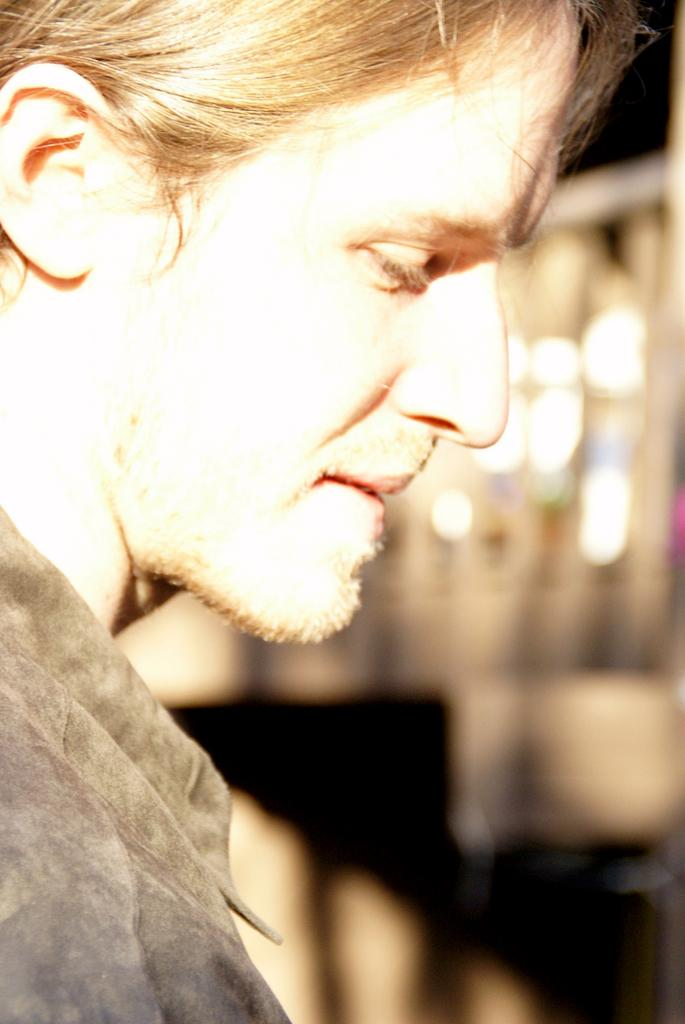What is the hair color of the person in the image? The person in the image has blonde hair. What type of clothing is the person wearing? The person is wearing a dress. Can you describe the background of the image? The background of the image contains blurry objects. What type of screw can be seen in the person's hair in the image? There is no screw present in the person's hair or in the image. 